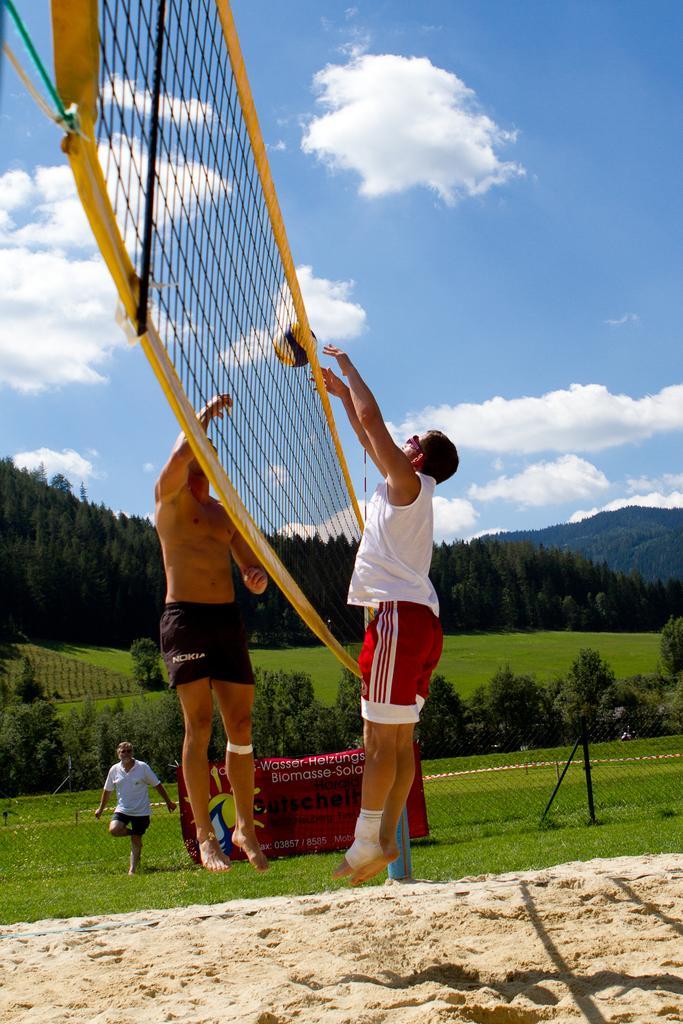How would you summarize this image in a sentence or two? In this image there are two people playing tennis ball, in between them there is a net, above the net there is a ball, behind them there is another person standing on the grass, there is net fence and a banner with some text. In the background there are trees and the sky. 